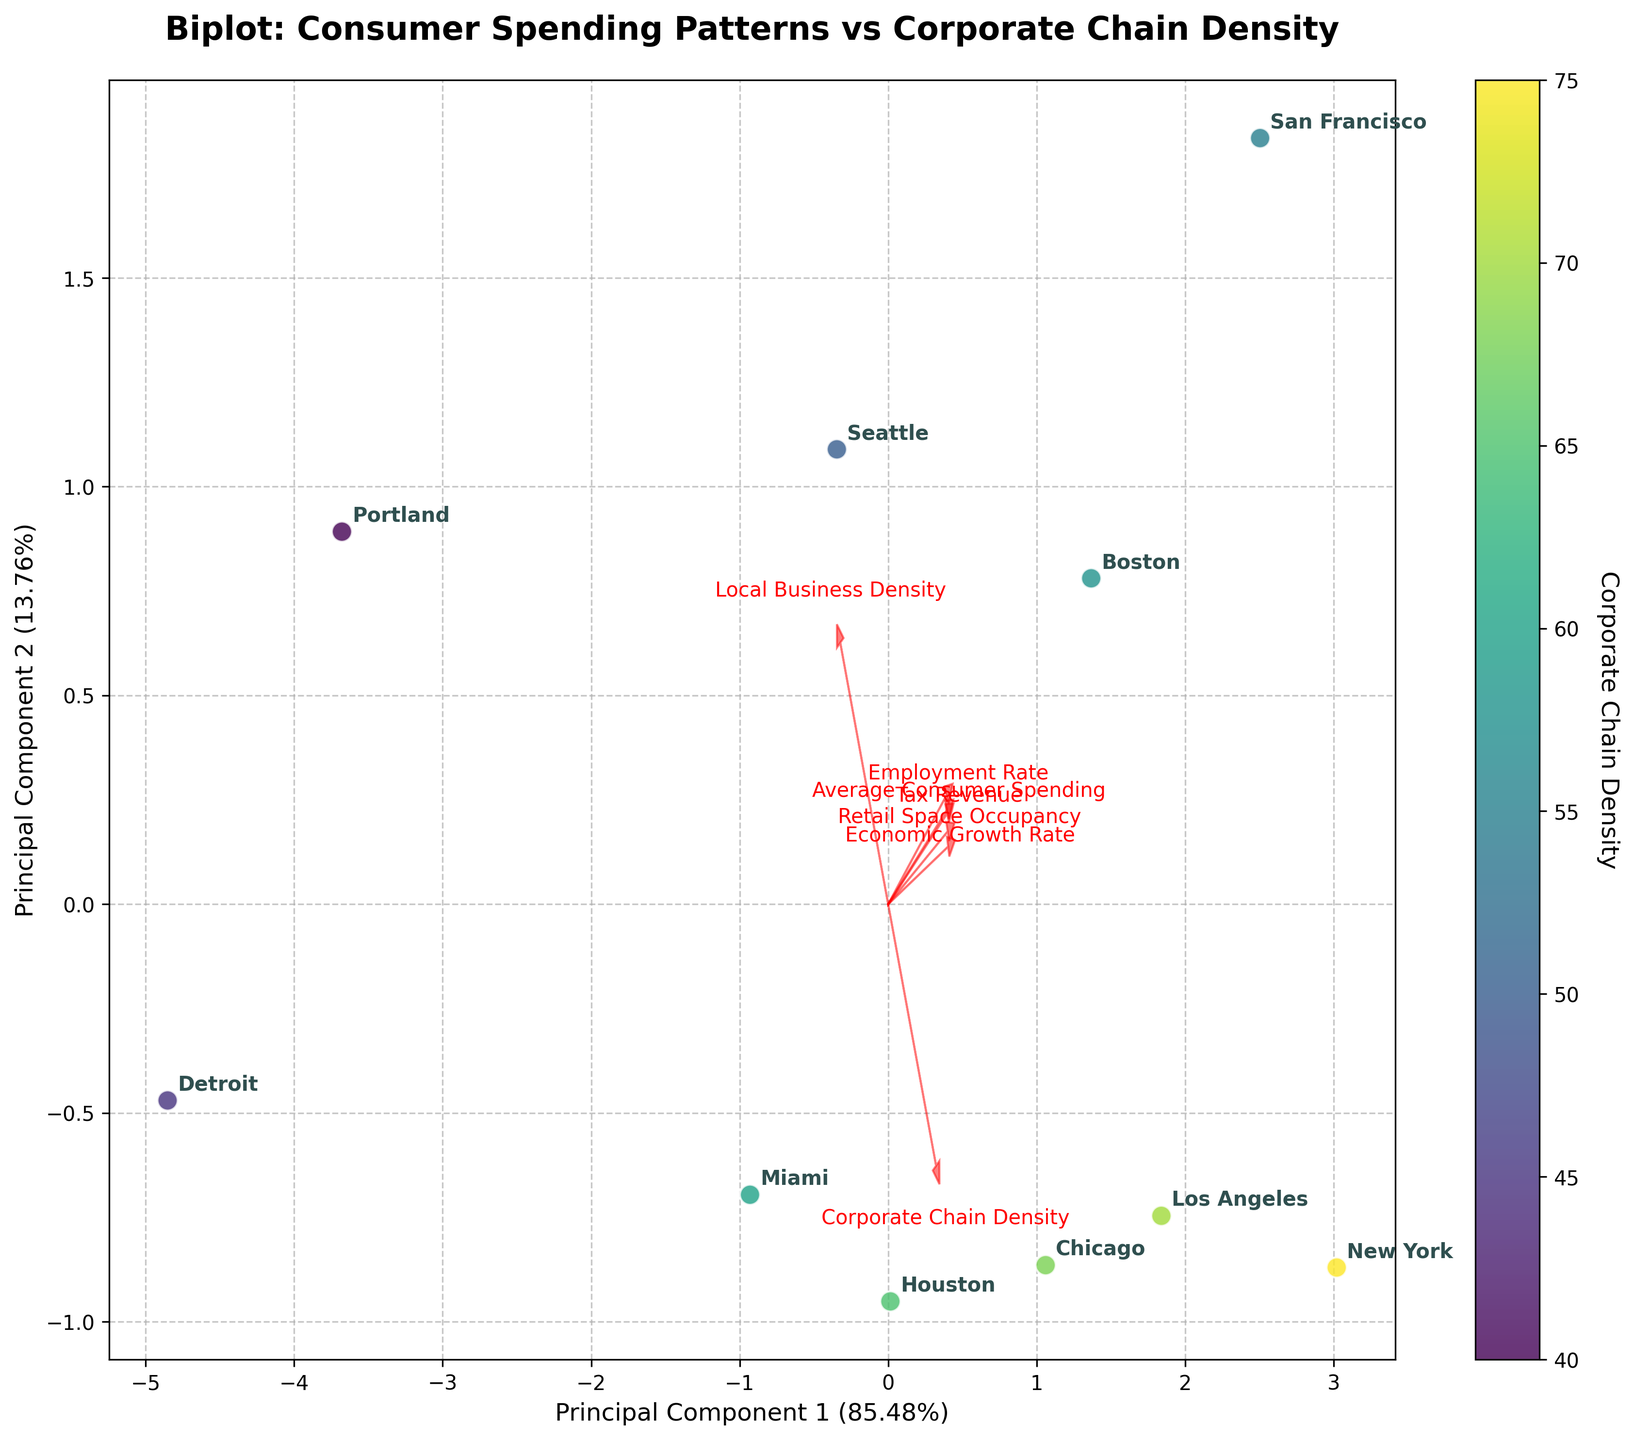How many principal components are displayed in the biplot? The plot shows two principal components on the x-axis and y-axis.
Answer: Two What does the color gradient in the scatter plot represent? The color gradient in the scatter plot represents the Corporate Chain Density of each city, as indicated by the colorbar on the right side of the plot.
Answer: Corporate Chain Density Which city has the highest value for Average Consumer Spending, as represented in the biplot? From the annotations in the biplot, the city with the highest Average Consumer Spending can be identified. The arrows for 'Average Consumer Spending' point towards San Francisco, indicating it has the highest value.
Answer: San Francisco Which principal component explains more variance, and what are their explained variance ratios? The labels on the x-axis and y-axis indicate the explained variance ratios of the principal components. Principal Component 1 has a higher variance ratio than Principal Component 2.
Answer: Principal Component 1 explains more variance What direction does the arrow for 'Economic Growth Rate' point towards, and what does it imply about the component it influences the most? The arrow for 'Economic Growth Rate' points towards the direction where the cities with higher economic growth rates are located. This direction helps to understand the relationship between the cities and this feature.
Answer: Towards the right and slightly upwards Compare the Corporate Chain Density and Economic Growth Rate between New York and Detroit based on their positions in the biplot. New York, positioned far from Detroit on the biplot, shows differences in both Corporate Chain Density and Economic Growth Rate. New York is towards the positive direction of the Corporate Chain Density and Economic Growth Rate arrows, indicating higher values.
Answer: New York has higher values for both Identify which city is closest to the origin (0,0) in the biplot and interpret what it means. The city closest to the origin point (0,0) in the biplot is Seattle. This suggests that its values for the features are close to the average of the dataset.
Answer: Seattle How are 'Employment Rate' and 'Retail Space Occupancy' related based on the directions of their arrows in the biplot? The arrows for 'Employment Rate' and 'Retail Space Occupancy' point in similar directions, suggesting a positive correlation between these two features.
Answer: Positively correlated Which cities have Corporate Chain Density closer to the average as implied by their positions relative to the Corporate Chain Density arrow? Cities like Miami and Houston are closer to the origin, indicating that their Corporate Chain Density is near the average for this dataset.
Answer: Miami and Houston 